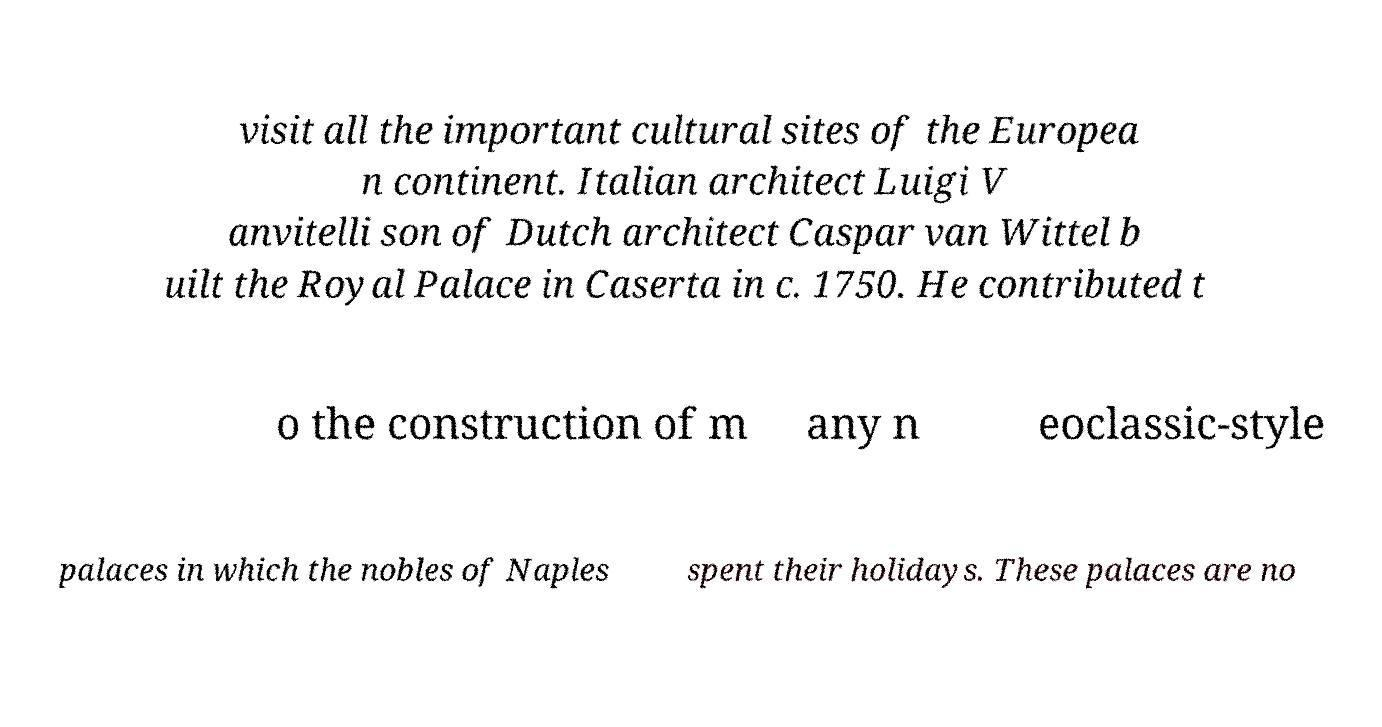I need the written content from this picture converted into text. Can you do that? visit all the important cultural sites of the Europea n continent. Italian architect Luigi V anvitelli son of Dutch architect Caspar van Wittel b uilt the Royal Palace in Caserta in c. 1750. He contributed t o the construction of m any n eoclassic-style palaces in which the nobles of Naples spent their holidays. These palaces are no 